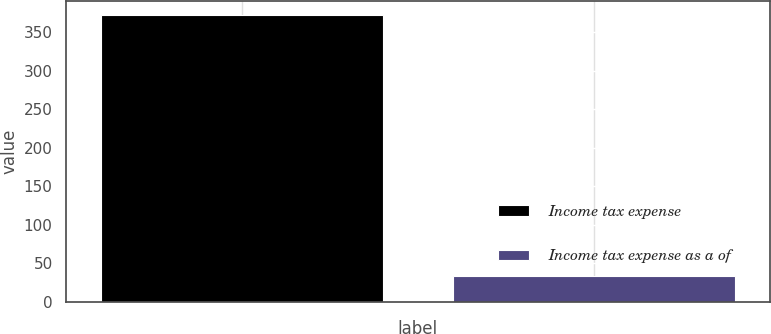Convert chart to OTSL. <chart><loc_0><loc_0><loc_500><loc_500><bar_chart><fcel>Income tax expense<fcel>Income tax expense as a of<nl><fcel>372.3<fcel>33.7<nl></chart> 